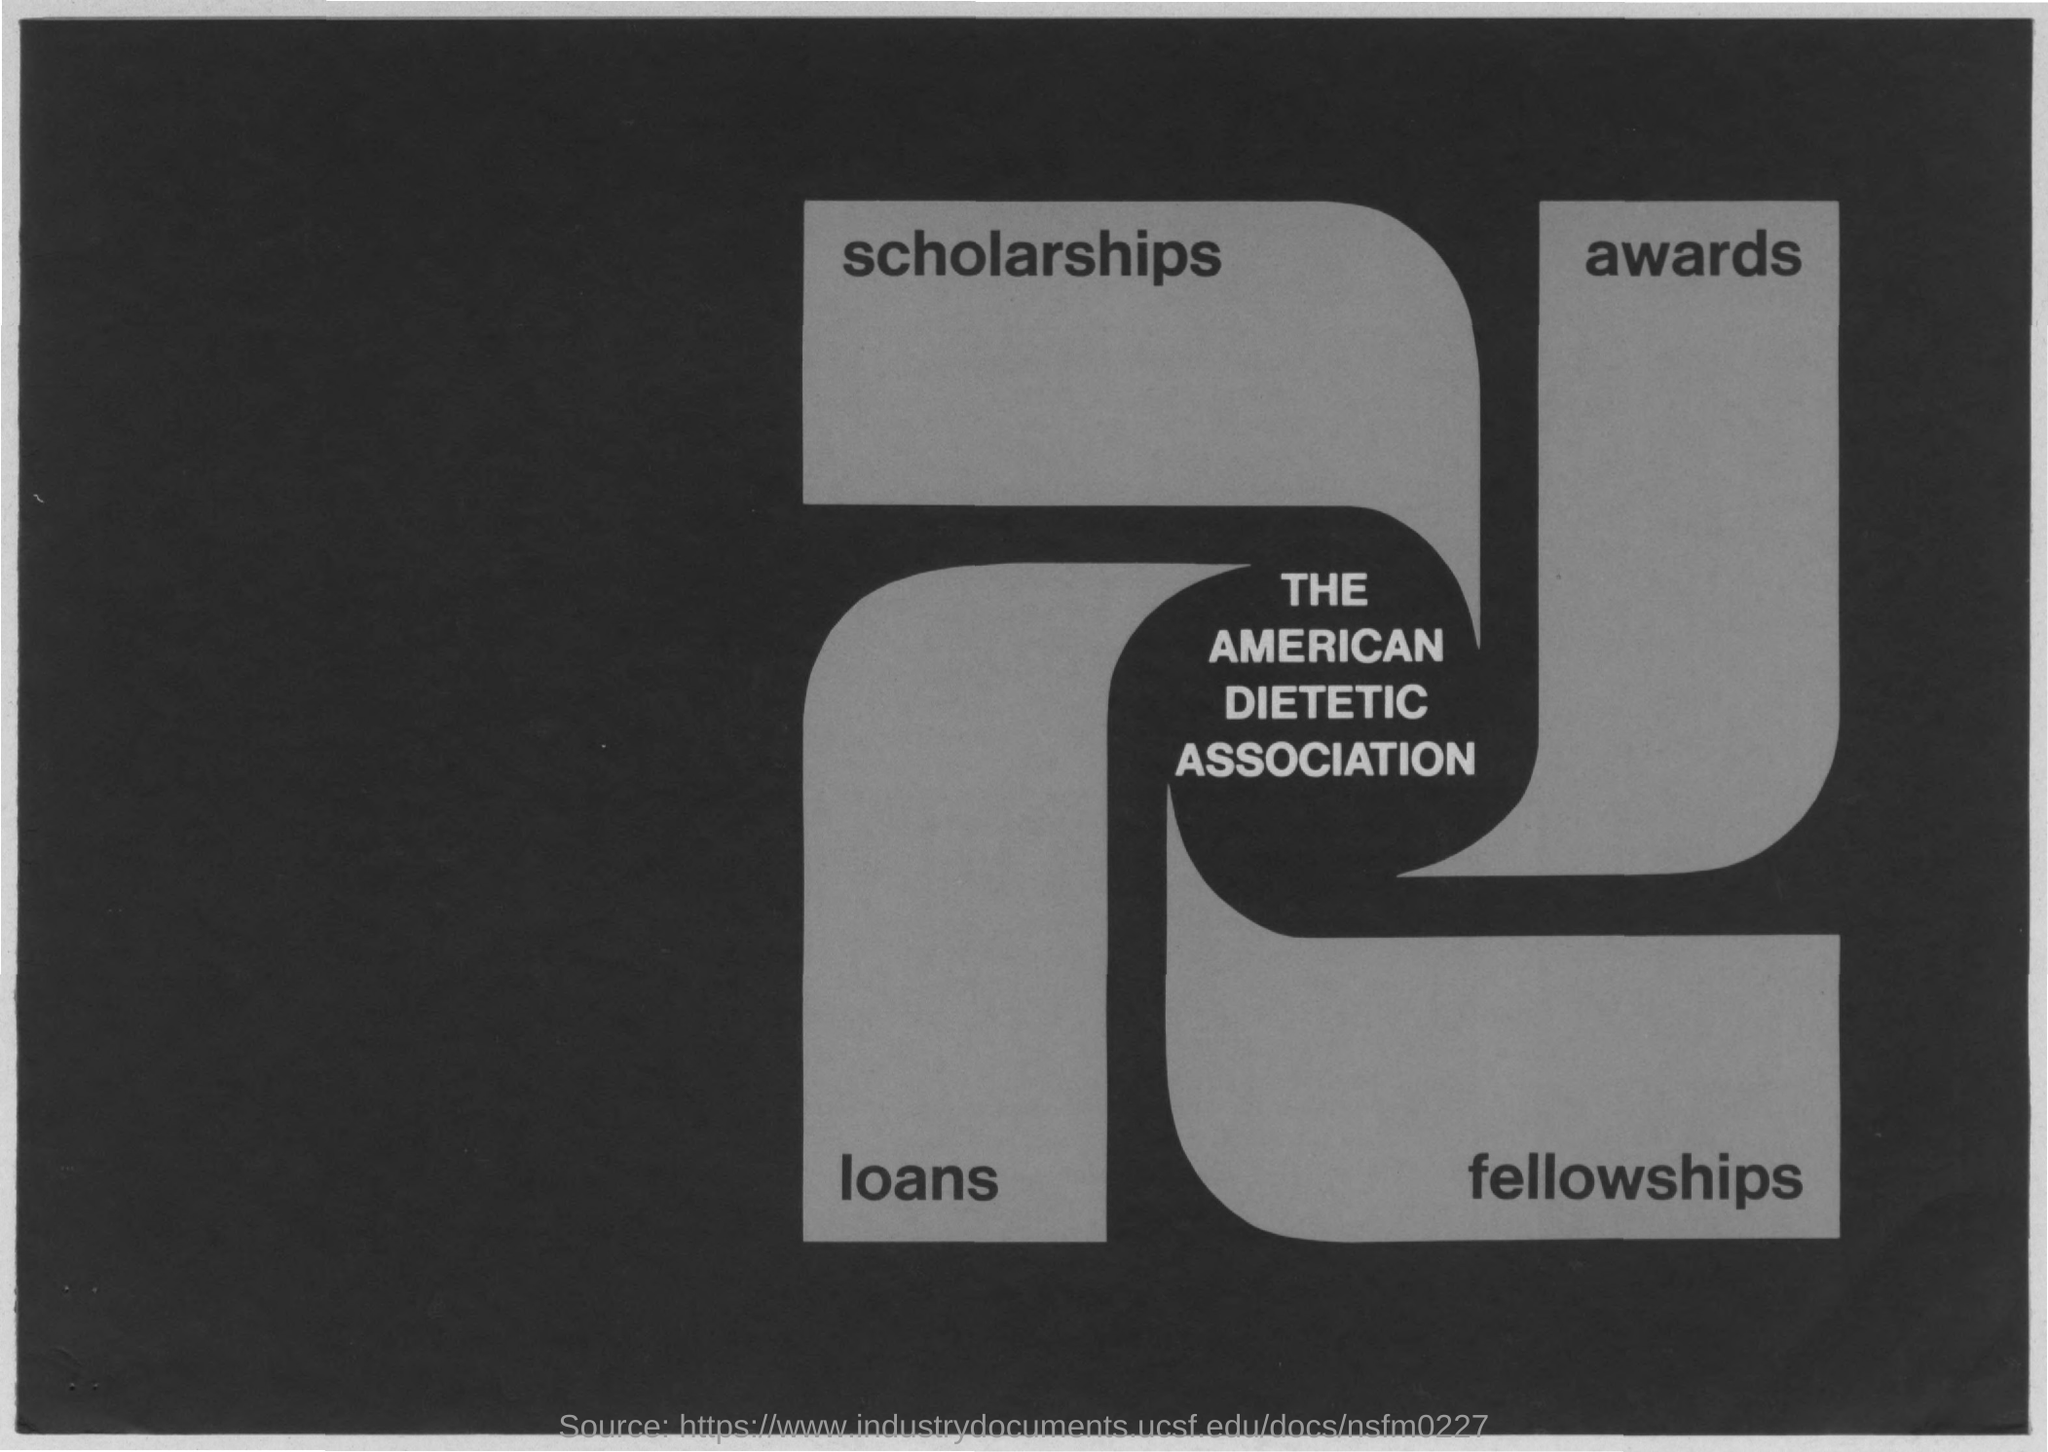Draw attention to some important aspects in this diagram. The text that is centered in the image is the name "The American Dietetic Association. The word 'fellowships' is written in the bottom right of the image. The top left corner of the image contains the written text 'scholarships'. In the bottom left of the image, it is written 'loans'. The top right of the image contains the word "awards. 